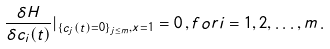<formula> <loc_0><loc_0><loc_500><loc_500>\frac { \delta H } { \delta c _ { i } ( t ) } | _ { \{ c _ { j } ( t ) = 0 \} _ { j \leq m } , x = 1 } = 0 \, , f o r i = 1 , 2 , \dots , m \, .</formula> 